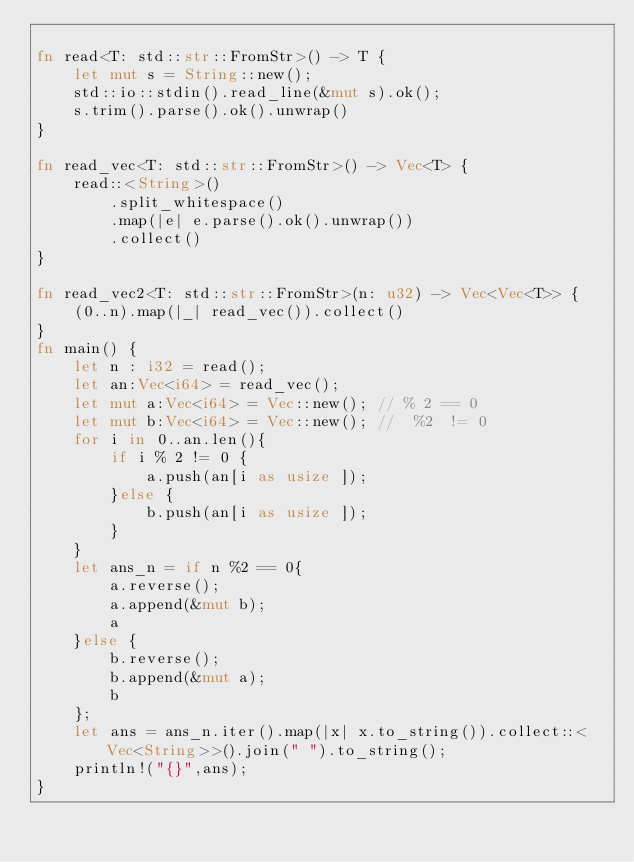<code> <loc_0><loc_0><loc_500><loc_500><_Rust_>
fn read<T: std::str::FromStr>() -> T {
    let mut s = String::new();
    std::io::stdin().read_line(&mut s).ok();
    s.trim().parse().ok().unwrap()
}

fn read_vec<T: std::str::FromStr>() -> Vec<T> {
    read::<String>()
        .split_whitespace()
        .map(|e| e.parse().ok().unwrap())
        .collect()
}

fn read_vec2<T: std::str::FromStr>(n: u32) -> Vec<Vec<T>> {
    (0..n).map(|_| read_vec()).collect()
}
fn main() {
    let n : i32 = read();
    let an:Vec<i64> = read_vec();
    let mut a:Vec<i64> = Vec::new(); // % 2 == 0
    let mut b:Vec<i64> = Vec::new(); //  %2  != 0
    for i in 0..an.len(){
        if i % 2 != 0 {
            a.push(an[i as usize ]);
        }else {
            b.push(an[i as usize ]);
        }
    }
    let ans_n = if n %2 == 0{
        a.reverse();
        a.append(&mut b);
        a
    }else {
        b.reverse();
        b.append(&mut a);
        b
    };
    let ans = ans_n.iter().map(|x| x.to_string()).collect::<Vec<String>>().join(" ").to_string();
    println!("{}",ans);
}</code> 